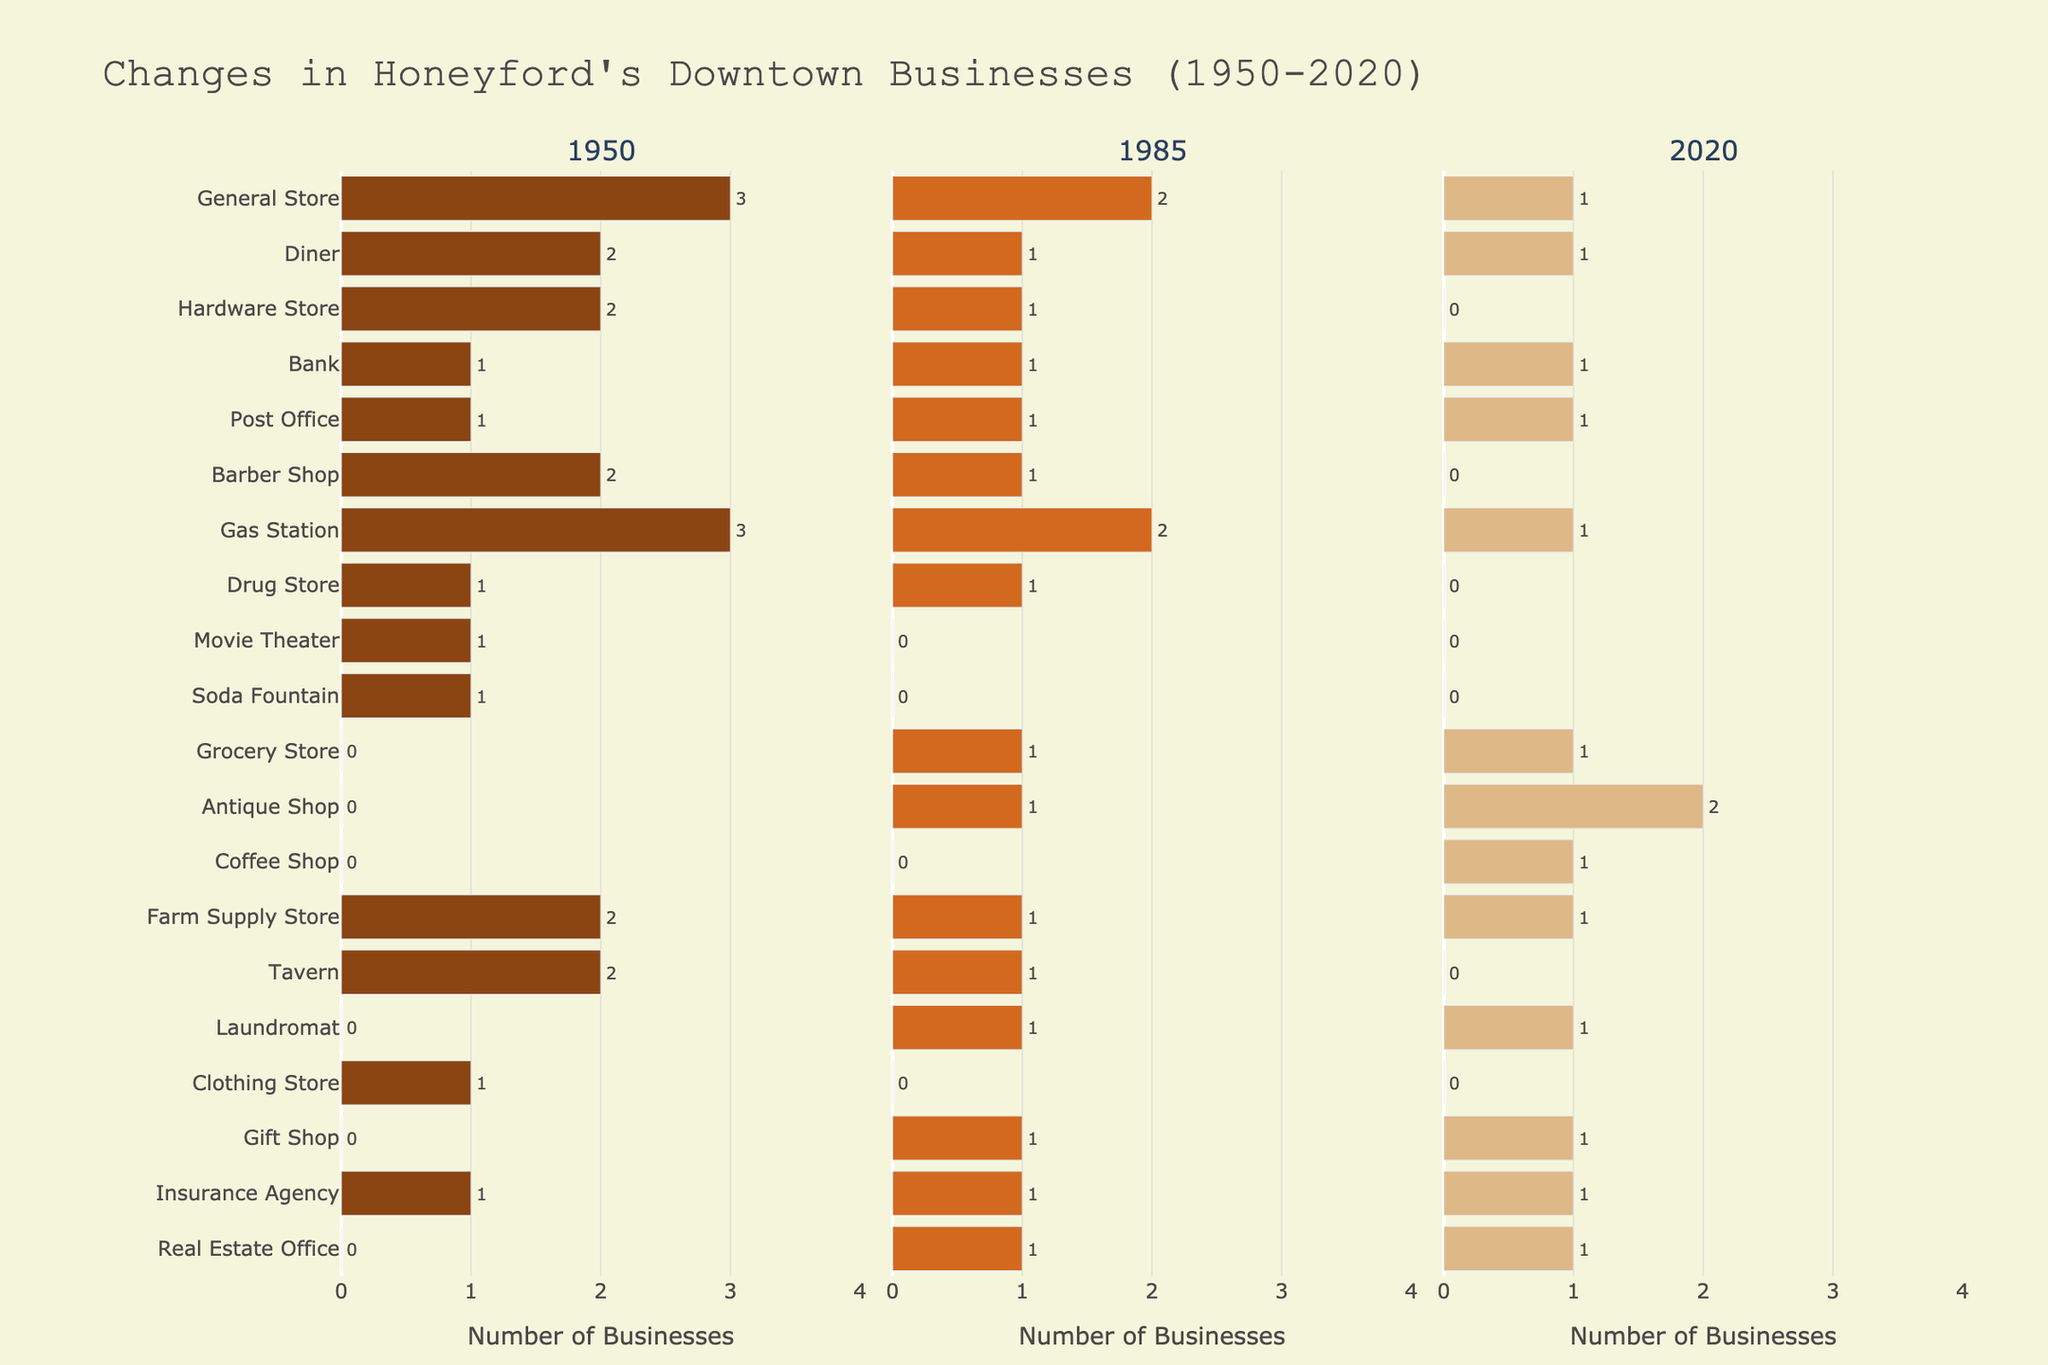What business type saw the largest decrease in the number of stores from 1950 to 2020? First, find the initial number of stores for each business type in 1950 and compare it to the number in 2020. Identify which business type had the most significant reduction in its count. General Store decreased from 3 to 1, Diner from 2 to 1, and so on. Many businesses disappeared entirely, but the General Store decreased the most by 2 units.
Answer: General Store Which year had the highest number of General Stores in Honeyford's downtown? Look at the bars representing General Stores across 1950, 1985, and 2020. Compare the lengths of these bars, where 1950 had 3 General Stores, 1985 had 2, and 2020 had 1.
Answer: 1950 How did the number of Gas Stations change from 1950 to 2020? Note the bar lengths for Gas Stations in each of the years: in 1950, there were 3; in 1985, there were 2; and in 2020, there is 1. Calculate the difference from 1950 to 2020: 3 - 1 = 2.
Answer: Decreased by 2 How many new business types appeared in Honeyford's downtown between 1985 and 2020? Identify the business types not present in 1985 but available in 2020. These are Grocery Store, Coffee Shop, and Antique Shop. Count them to determine the total.
Answer: 3 Which businesses have remained constant in number from 1950 through 2020? Examine the number of businesses of each type for all three years. Identify those with identical values across all years. Post Office, Bank, Insurance Agency have remained constant with 1 across 1950, 1985, and 2020.
Answer: Bank, Post Office, Insurance Agency What is the total number of new business types added in 2020 compared to 1950? Check the list of business types in 2020 that did not exist in 1950. These include Grocery Store, Antique Shop, Coffee Shop, Laundromat, and Gift Shop. Count these new additions.
Answer: 5 Which year had the lowest number of Diner businesses? Observe the bars for Diner in each year. 1950 had 2, 1985 had 1, and 2020 had 1. Both 1985 and 2020 had the lowest number of 1.
Answer: 1985, 2020 How many total businesses were there in 1985? Sum up the count of all businesses in 1985 by adding the numbers beside each business type bar in 1985.
Answer: 15 